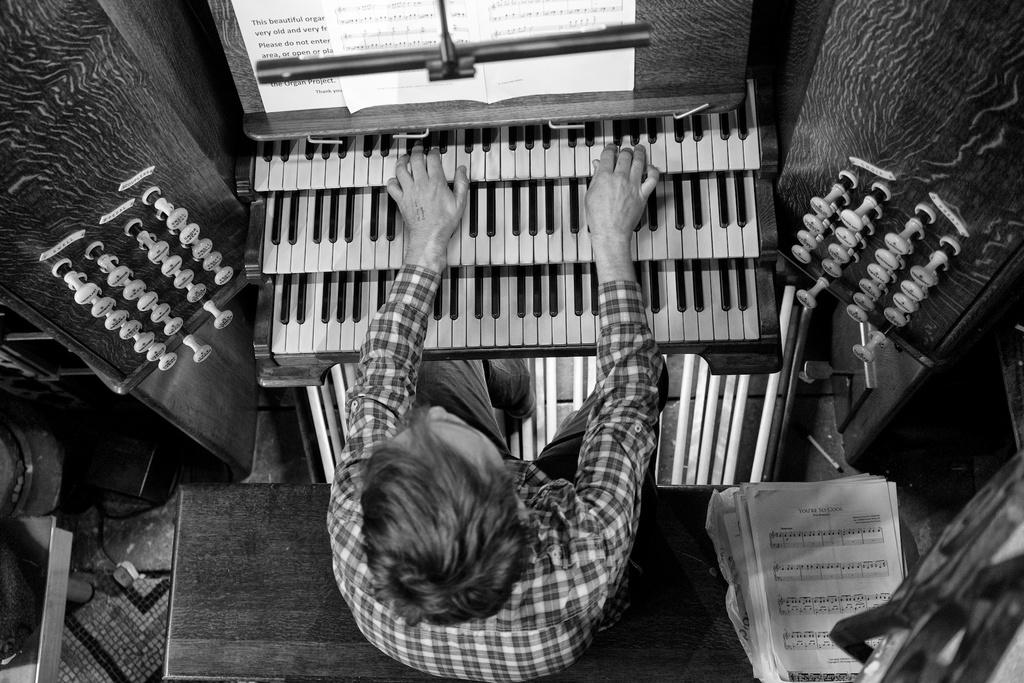What is the color scheme of the image? The image is black and white. What is the person in the image doing? The person is sitting on a bench and playing a keyboard. What type of canvas is the person using to cover the keyboard in the image? There is no canvas or cover present in the image; the person is playing a keyboard without any visible cover. 